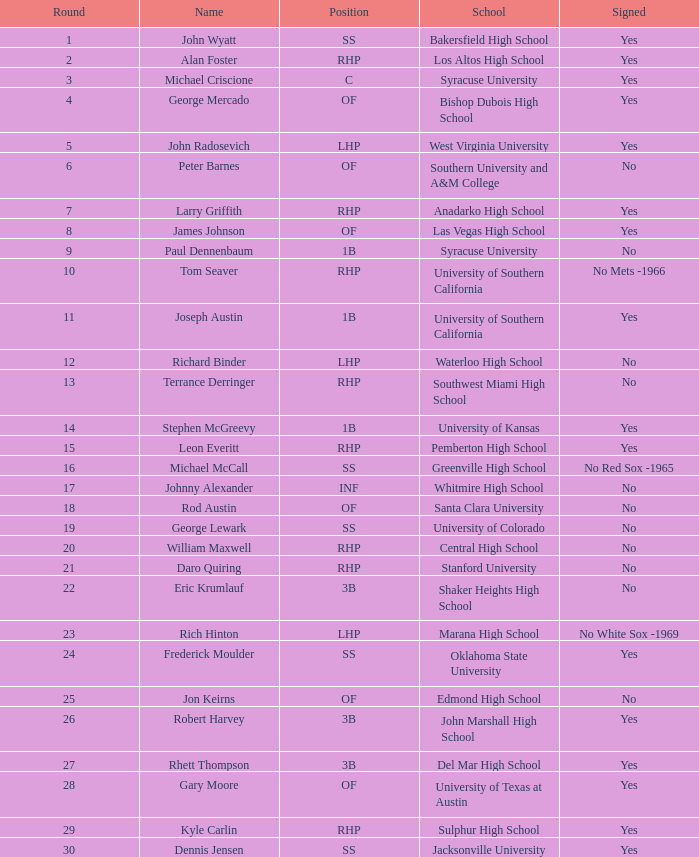What is the name of the player taken in round 23? Rich Hinton. Write the full table. {'header': ['Round', 'Name', 'Position', 'School', 'Signed'], 'rows': [['1', 'John Wyatt', 'SS', 'Bakersfield High School', 'Yes'], ['2', 'Alan Foster', 'RHP', 'Los Altos High School', 'Yes'], ['3', 'Michael Criscione', 'C', 'Syracuse University', 'Yes'], ['4', 'George Mercado', 'OF', 'Bishop Dubois High School', 'Yes'], ['5', 'John Radosevich', 'LHP', 'West Virginia University', 'Yes'], ['6', 'Peter Barnes', 'OF', 'Southern University and A&M College', 'No'], ['7', 'Larry Griffith', 'RHP', 'Anadarko High School', 'Yes'], ['8', 'James Johnson', 'OF', 'Las Vegas High School', 'Yes'], ['9', 'Paul Dennenbaum', '1B', 'Syracuse University', 'No'], ['10', 'Tom Seaver', 'RHP', 'University of Southern California', 'No Mets -1966'], ['11', 'Joseph Austin', '1B', 'University of Southern California', 'Yes'], ['12', 'Richard Binder', 'LHP', 'Waterloo High School', 'No'], ['13', 'Terrance Derringer', 'RHP', 'Southwest Miami High School', 'No'], ['14', 'Stephen McGreevy', '1B', 'University of Kansas', 'Yes'], ['15', 'Leon Everitt', 'RHP', 'Pemberton High School', 'Yes'], ['16', 'Michael McCall', 'SS', 'Greenville High School', 'No Red Sox -1965'], ['17', 'Johnny Alexander', 'INF', 'Whitmire High School', 'No'], ['18', 'Rod Austin', 'OF', 'Santa Clara University', 'No'], ['19', 'George Lewark', 'SS', 'University of Colorado', 'No'], ['20', 'William Maxwell', 'RHP', 'Central High School', 'No'], ['21', 'Daro Quiring', 'RHP', 'Stanford University', 'No'], ['22', 'Eric Krumlauf', '3B', 'Shaker Heights High School', 'No'], ['23', 'Rich Hinton', 'LHP', 'Marana High School', 'No White Sox -1969'], ['24', 'Frederick Moulder', 'SS', 'Oklahoma State University', 'Yes'], ['25', 'Jon Keirns', 'OF', 'Edmond High School', 'No'], ['26', 'Robert Harvey', '3B', 'John Marshall High School', 'Yes'], ['27', 'Rhett Thompson', '3B', 'Del Mar High School', 'Yes'], ['28', 'Gary Moore', 'OF', 'University of Texas at Austin', 'Yes'], ['29', 'Kyle Carlin', 'RHP', 'Sulphur High School', 'Yes'], ['30', 'Dennis Jensen', 'SS', 'Jacksonville University', 'Yes']]} 